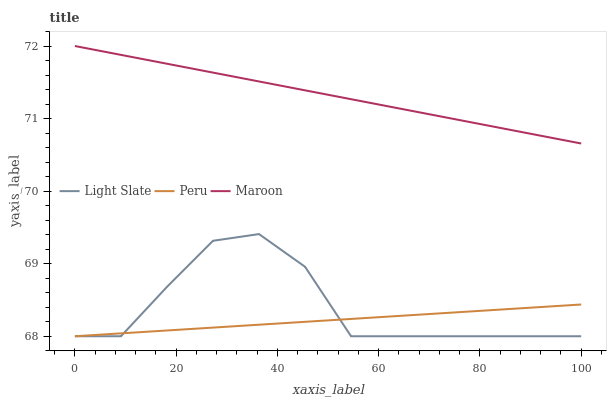Does Peru have the minimum area under the curve?
Answer yes or no. Yes. Does Maroon have the maximum area under the curve?
Answer yes or no. Yes. Does Maroon have the minimum area under the curve?
Answer yes or no. No. Does Peru have the maximum area under the curve?
Answer yes or no. No. Is Peru the smoothest?
Answer yes or no. Yes. Is Light Slate the roughest?
Answer yes or no. Yes. Is Maroon the smoothest?
Answer yes or no. No. Is Maroon the roughest?
Answer yes or no. No. Does Light Slate have the lowest value?
Answer yes or no. Yes. Does Maroon have the lowest value?
Answer yes or no. No. Does Maroon have the highest value?
Answer yes or no. Yes. Does Peru have the highest value?
Answer yes or no. No. Is Peru less than Maroon?
Answer yes or no. Yes. Is Maroon greater than Peru?
Answer yes or no. Yes. Does Peru intersect Light Slate?
Answer yes or no. Yes. Is Peru less than Light Slate?
Answer yes or no. No. Is Peru greater than Light Slate?
Answer yes or no. No. Does Peru intersect Maroon?
Answer yes or no. No. 